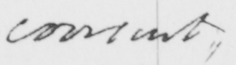Please provide the text content of this handwritten line. consent 